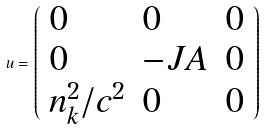Convert formula to latex. <formula><loc_0><loc_0><loc_500><loc_500>u = \left ( \begin{array} { l l l } 0 & 0 & 0 \\ 0 & - J A & 0 \\ n _ { k } ^ { 2 } / c ^ { 2 } & 0 & 0 \end{array} \right )</formula> 